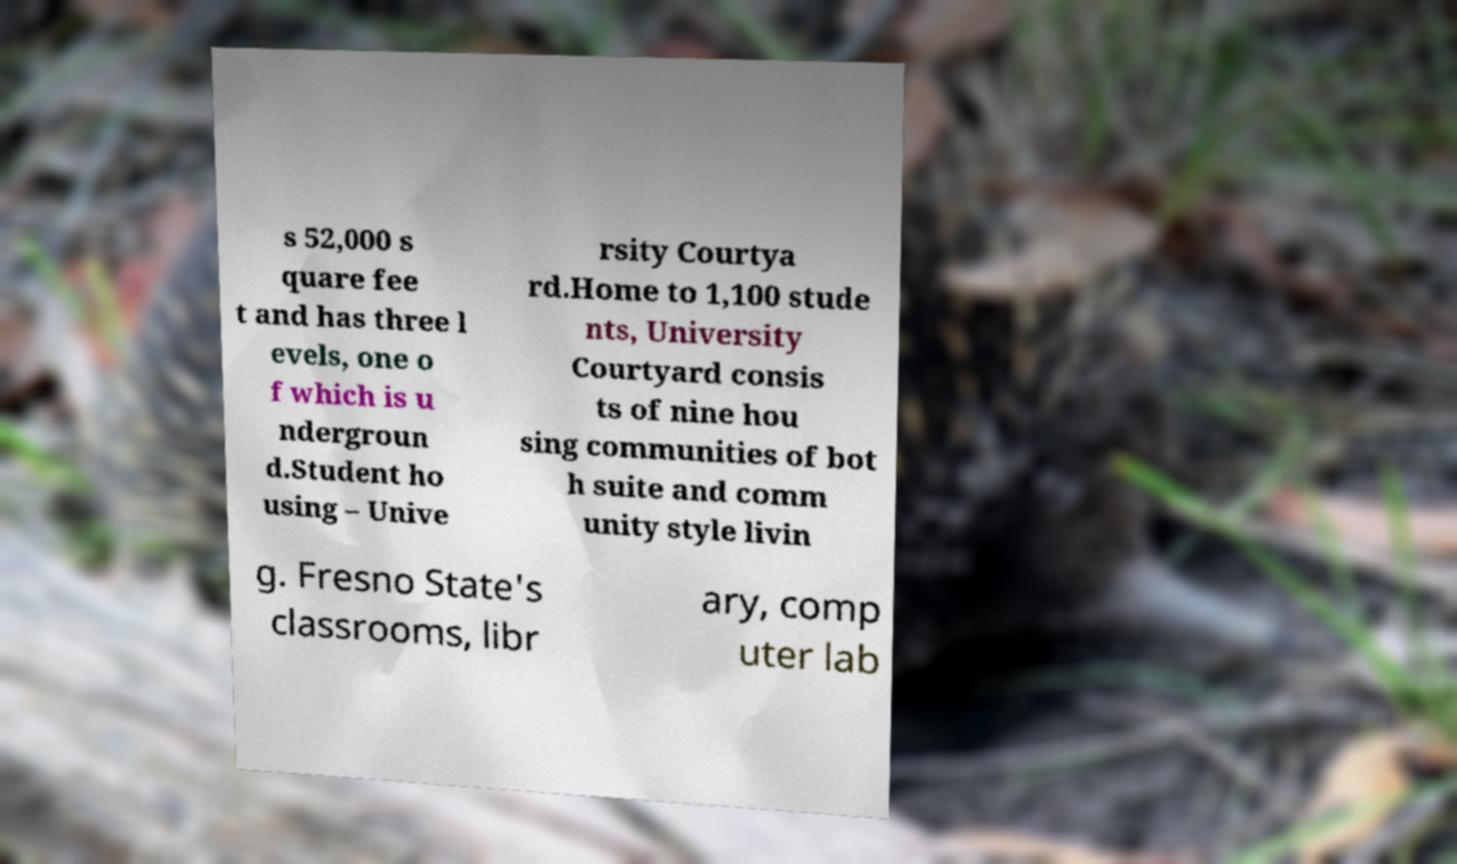Could you extract and type out the text from this image? s 52,000 s quare fee t and has three l evels, one o f which is u ndergroun d.Student ho using – Unive rsity Courtya rd.Home to 1,100 stude nts, University Courtyard consis ts of nine hou sing communities of bot h suite and comm unity style livin g. Fresno State's classrooms, libr ary, comp uter lab 